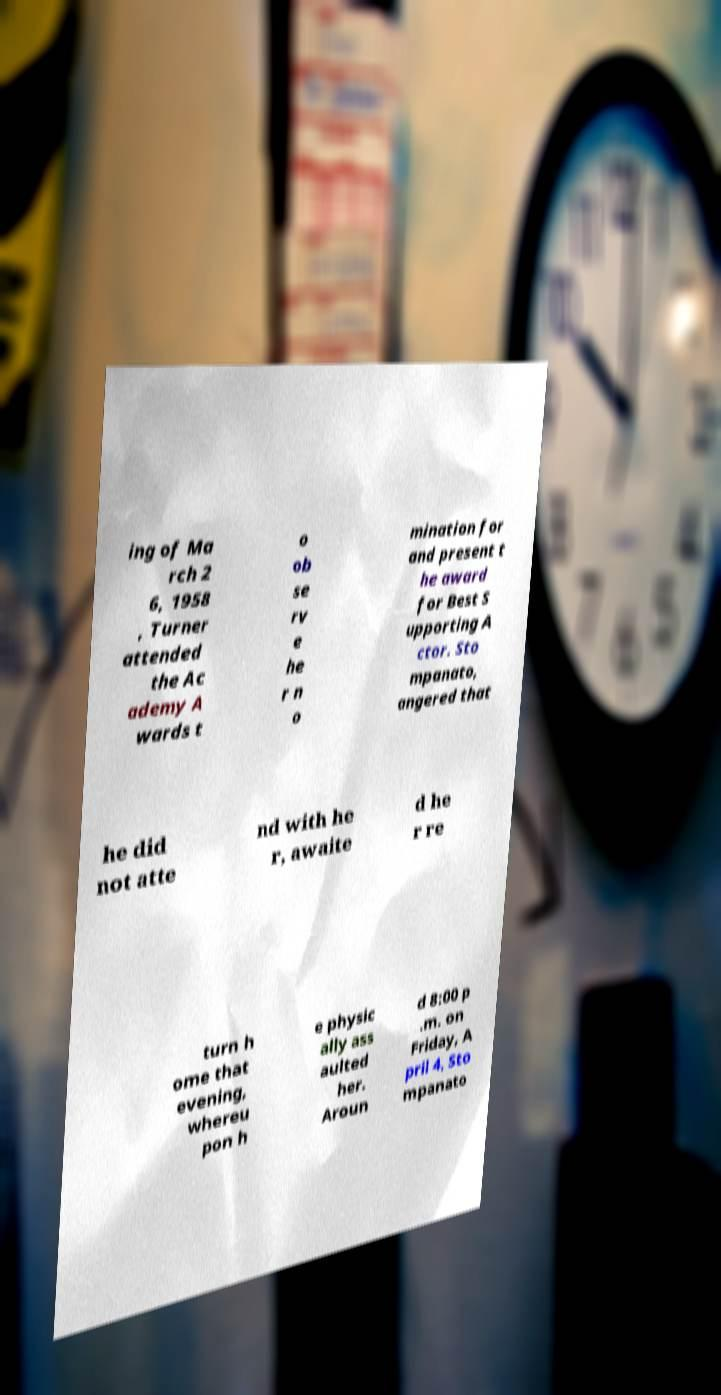There's text embedded in this image that I need extracted. Can you transcribe it verbatim? ing of Ma rch 2 6, 1958 , Turner attended the Ac ademy A wards t o ob se rv e he r n o mination for and present t he award for Best S upporting A ctor. Sto mpanato, angered that he did not atte nd with he r, awaite d he r re turn h ome that evening, whereu pon h e physic ally ass aulted her. Aroun d 8:00 p .m. on Friday, A pril 4, Sto mpanato 